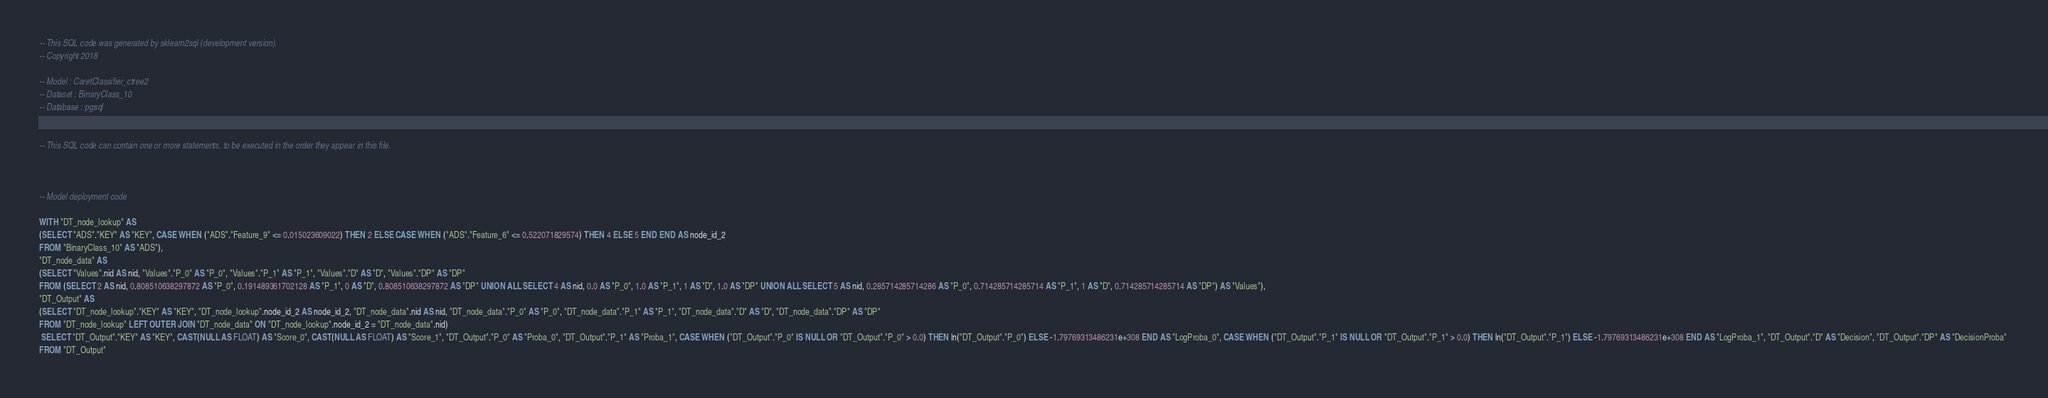Convert code to text. <code><loc_0><loc_0><loc_500><loc_500><_SQL_>-- This SQL code was generated by sklearn2sql (development version).
-- Copyright 2018

-- Model : CaretClassifier_ctree2
-- Dataset : BinaryClass_10
-- Database : pgsql


-- This SQL code can contain one or more statements, to be executed in the order they appear in this file.



-- Model deployment code

WITH "DT_node_lookup" AS 
(SELECT "ADS"."KEY" AS "KEY", CASE WHEN ("ADS"."Feature_9" <= 0.015023609022) THEN 2 ELSE CASE WHEN ("ADS"."Feature_6" <= 0.522071829574) THEN 4 ELSE 5 END END AS node_id_2 
FROM "BinaryClass_10" AS "ADS"), 
"DT_node_data" AS 
(SELECT "Values".nid AS nid, "Values"."P_0" AS "P_0", "Values"."P_1" AS "P_1", "Values"."D" AS "D", "Values"."DP" AS "DP" 
FROM (SELECT 2 AS nid, 0.808510638297872 AS "P_0", 0.191489361702128 AS "P_1", 0 AS "D", 0.808510638297872 AS "DP" UNION ALL SELECT 4 AS nid, 0.0 AS "P_0", 1.0 AS "P_1", 1 AS "D", 1.0 AS "DP" UNION ALL SELECT 5 AS nid, 0.285714285714286 AS "P_0", 0.714285714285714 AS "P_1", 1 AS "D", 0.714285714285714 AS "DP") AS "Values"), 
"DT_Output" AS 
(SELECT "DT_node_lookup"."KEY" AS "KEY", "DT_node_lookup".node_id_2 AS node_id_2, "DT_node_data".nid AS nid, "DT_node_data"."P_0" AS "P_0", "DT_node_data"."P_1" AS "P_1", "DT_node_data"."D" AS "D", "DT_node_data"."DP" AS "DP" 
FROM "DT_node_lookup" LEFT OUTER JOIN "DT_node_data" ON "DT_node_lookup".node_id_2 = "DT_node_data".nid)
 SELECT "DT_Output"."KEY" AS "KEY", CAST(NULL AS FLOAT) AS "Score_0", CAST(NULL AS FLOAT) AS "Score_1", "DT_Output"."P_0" AS "Proba_0", "DT_Output"."P_1" AS "Proba_1", CASE WHEN ("DT_Output"."P_0" IS NULL OR "DT_Output"."P_0" > 0.0) THEN ln("DT_Output"."P_0") ELSE -1.79769313486231e+308 END AS "LogProba_0", CASE WHEN ("DT_Output"."P_1" IS NULL OR "DT_Output"."P_1" > 0.0) THEN ln("DT_Output"."P_1") ELSE -1.79769313486231e+308 END AS "LogProba_1", "DT_Output"."D" AS "Decision", "DT_Output"."DP" AS "DecisionProba" 
FROM "DT_Output"</code> 